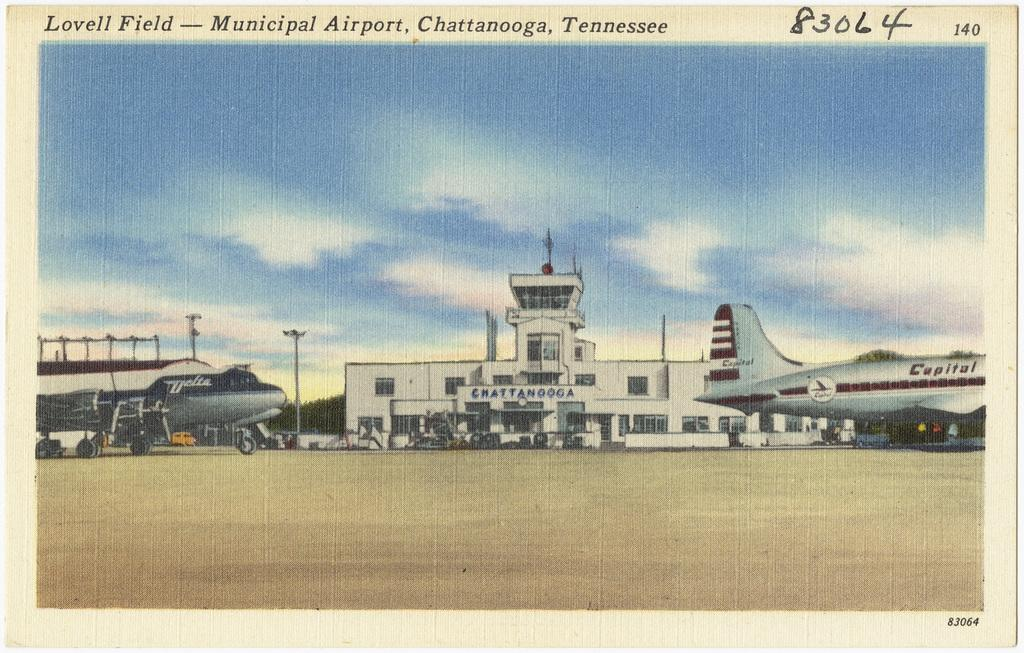What type of structure is visible in the image? There is a building in the image. What is located on top of the building? Antennas are present on top of the building. Can you describe the airplanes in the image? There is an airplane on the right side of the image and another airplane on the left side of the image. What type of hill can be seen in the background of the image? There is no hill visible in the image. Can you hear the bells ringing in the image? There are no bells or any indication of sound in the image. 